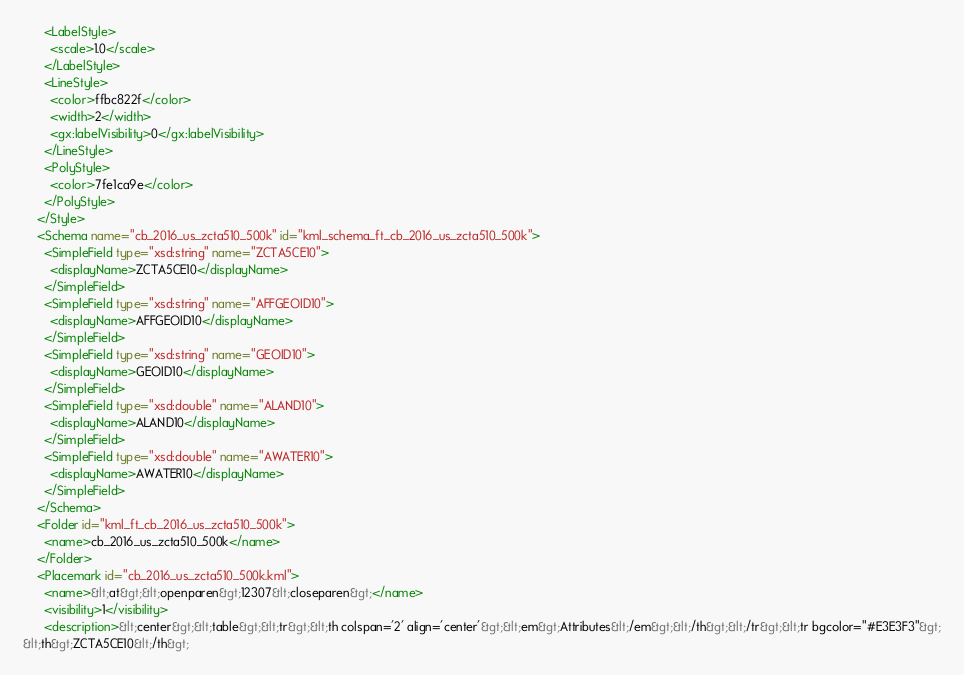<code> <loc_0><loc_0><loc_500><loc_500><_XML_>      <LabelStyle>
        <scale>1.0</scale>
      </LabelStyle>
      <LineStyle>
        <color>ffbc822f</color>
        <width>2</width>
        <gx:labelVisibility>0</gx:labelVisibility>
      </LineStyle>
      <PolyStyle>
        <color>7fe1ca9e</color>
      </PolyStyle>
    </Style>
    <Schema name="cb_2016_us_zcta510_500k" id="kml_schema_ft_cb_2016_us_zcta510_500k">
      <SimpleField type="xsd:string" name="ZCTA5CE10">
        <displayName>ZCTA5CE10</displayName>
      </SimpleField>
      <SimpleField type="xsd:string" name="AFFGEOID10">
        <displayName>AFFGEOID10</displayName>
      </SimpleField>
      <SimpleField type="xsd:string" name="GEOID10">
        <displayName>GEOID10</displayName>
      </SimpleField>
      <SimpleField type="xsd:double" name="ALAND10">
        <displayName>ALAND10</displayName>
      </SimpleField>
      <SimpleField type="xsd:double" name="AWATER10">
        <displayName>AWATER10</displayName>
      </SimpleField>
    </Schema>
    <Folder id="kml_ft_cb_2016_us_zcta510_500k">
      <name>cb_2016_us_zcta510_500k</name>
    </Folder>
    <Placemark id="cb_2016_us_zcta510_500k.kml">
      <name>&lt;at&gt;&lt;openparen&gt;12307&lt;closeparen&gt;</name>
      <visibility>1</visibility>
      <description>&lt;center&gt;&lt;table&gt;&lt;tr&gt;&lt;th colspan='2' align='center'&gt;&lt;em&gt;Attributes&lt;/em&gt;&lt;/th&gt;&lt;/tr&gt;&lt;tr bgcolor="#E3E3F3"&gt;
&lt;th&gt;ZCTA5CE10&lt;/th&gt;</code> 